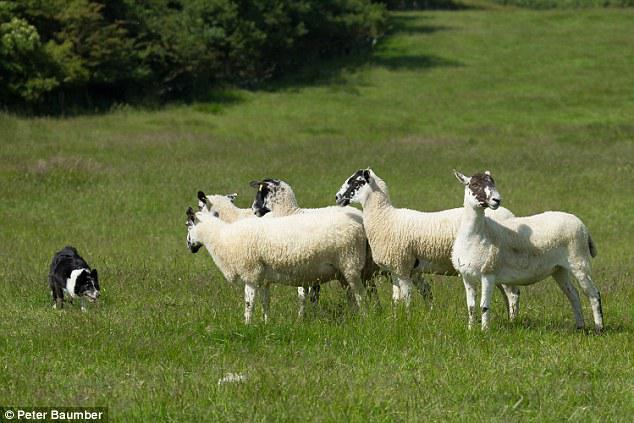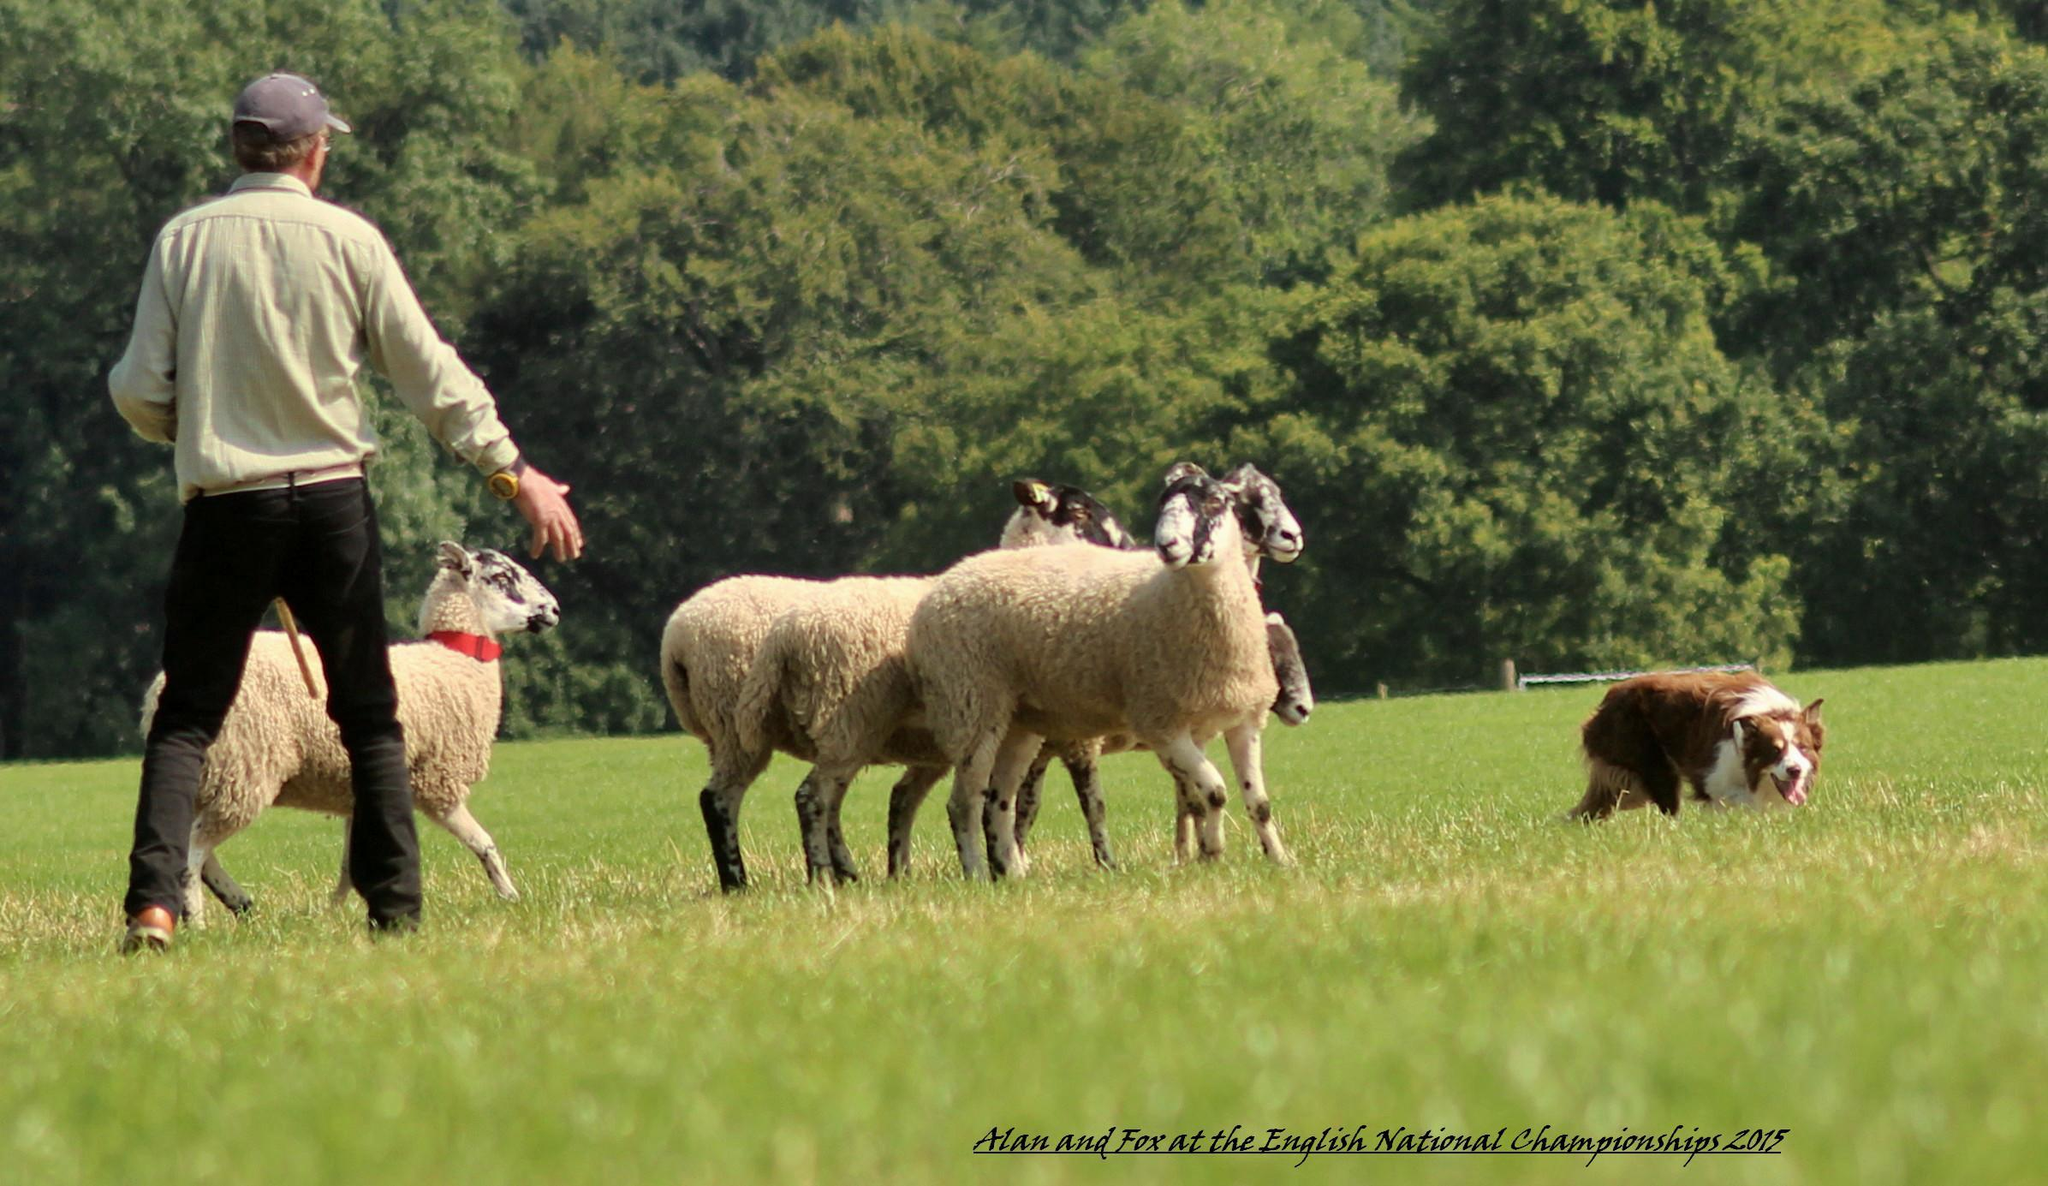The first image is the image on the left, the second image is the image on the right. Examine the images to the left and right. Is the description "One image shows a dog to the right of sheep, and the other shows a dog to the left of sheep." accurate? Answer yes or no. Yes. 